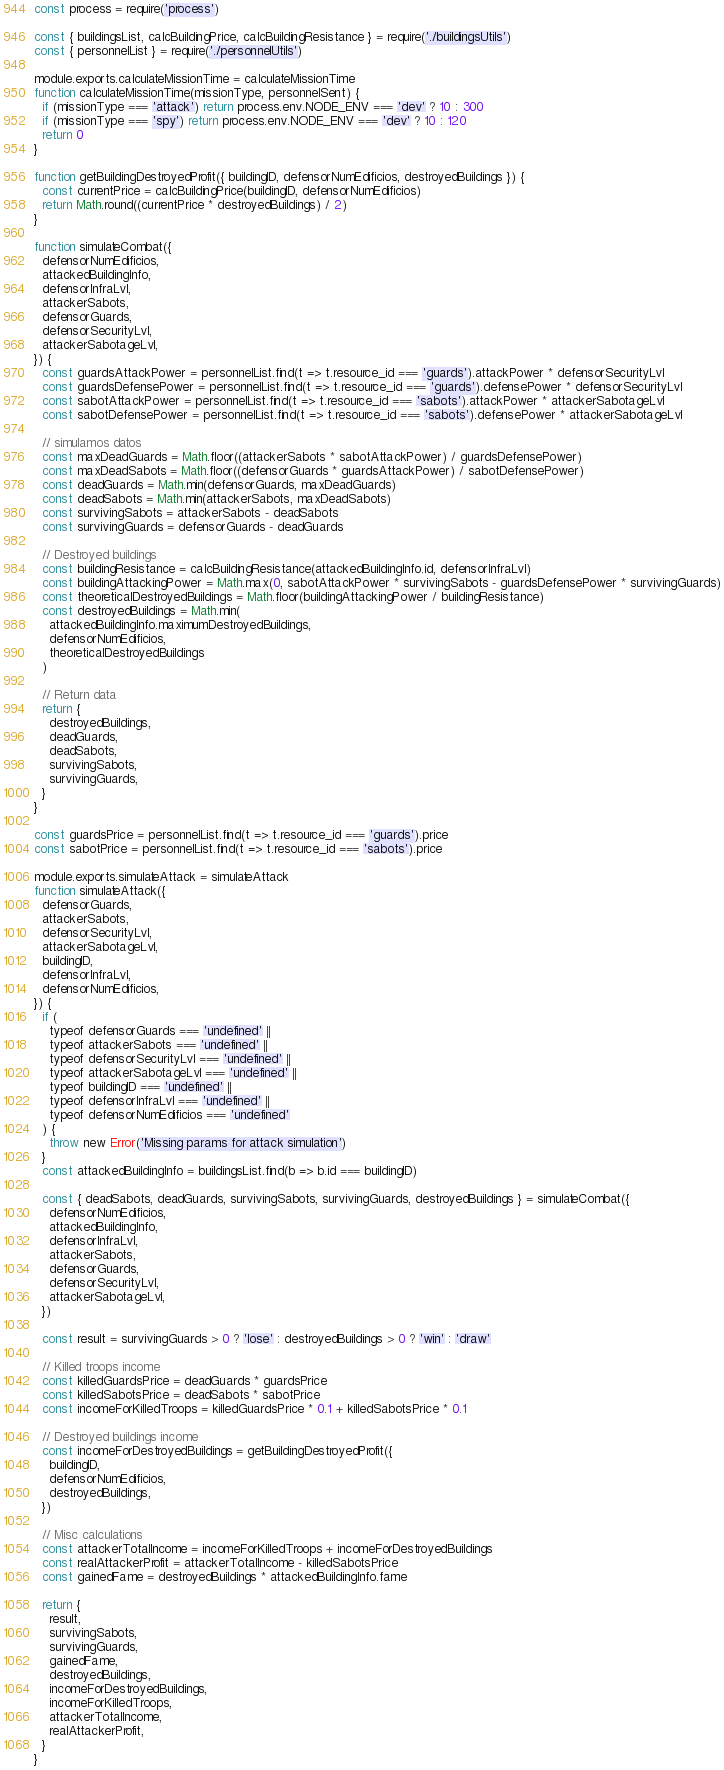<code> <loc_0><loc_0><loc_500><loc_500><_JavaScript_>const process = require('process')

const { buildingsList, calcBuildingPrice, calcBuildingResistance } = require('./buildingsUtils')
const { personnelList } = require('./personnelUtils')

module.exports.calculateMissionTime = calculateMissionTime
function calculateMissionTime(missionType, personnelSent) {
  if (missionType === 'attack') return process.env.NODE_ENV === 'dev' ? 10 : 300
  if (missionType === 'spy') return process.env.NODE_ENV === 'dev' ? 10 : 120
  return 0
}

function getBuildingDestroyedProfit({ buildingID, defensorNumEdificios, destroyedBuildings }) {
  const currentPrice = calcBuildingPrice(buildingID, defensorNumEdificios)
  return Math.round((currentPrice * destroyedBuildings) / 2)
}

function simulateCombat({
  defensorNumEdificios,
  attackedBuildingInfo,
  defensorInfraLvl,
  attackerSabots,
  defensorGuards,
  defensorSecurityLvl,
  attackerSabotageLvl,
}) {
  const guardsAttackPower = personnelList.find(t => t.resource_id === 'guards').attackPower * defensorSecurityLvl
  const guardsDefensePower = personnelList.find(t => t.resource_id === 'guards').defensePower * defensorSecurityLvl
  const sabotAttackPower = personnelList.find(t => t.resource_id === 'sabots').attackPower * attackerSabotageLvl
  const sabotDefensePower = personnelList.find(t => t.resource_id === 'sabots').defensePower * attackerSabotageLvl

  // simulamos datos
  const maxDeadGuards = Math.floor((attackerSabots * sabotAttackPower) / guardsDefensePower)
  const maxDeadSabots = Math.floor((defensorGuards * guardsAttackPower) / sabotDefensePower)
  const deadGuards = Math.min(defensorGuards, maxDeadGuards)
  const deadSabots = Math.min(attackerSabots, maxDeadSabots)
  const survivingSabots = attackerSabots - deadSabots
  const survivingGuards = defensorGuards - deadGuards

  // Destroyed buildings
  const buildingResistance = calcBuildingResistance(attackedBuildingInfo.id, defensorInfraLvl)
  const buildingAttackingPower = Math.max(0, sabotAttackPower * survivingSabots - guardsDefensePower * survivingGuards)
  const theoreticalDestroyedBuildings = Math.floor(buildingAttackingPower / buildingResistance)
  const destroyedBuildings = Math.min(
    attackedBuildingInfo.maximumDestroyedBuildings,
    defensorNumEdificios,
    theoreticalDestroyedBuildings
  )

  // Return data
  return {
    destroyedBuildings,
    deadGuards,
    deadSabots,
    survivingSabots,
    survivingGuards,
  }
}

const guardsPrice = personnelList.find(t => t.resource_id === 'guards').price
const sabotPrice = personnelList.find(t => t.resource_id === 'sabots').price

module.exports.simulateAttack = simulateAttack
function simulateAttack({
  defensorGuards,
  attackerSabots,
  defensorSecurityLvl,
  attackerSabotageLvl,
  buildingID,
  defensorInfraLvl,
  defensorNumEdificios,
}) {
  if (
    typeof defensorGuards === 'undefined' ||
    typeof attackerSabots === 'undefined' ||
    typeof defensorSecurityLvl === 'undefined' ||
    typeof attackerSabotageLvl === 'undefined' ||
    typeof buildingID === 'undefined' ||
    typeof defensorInfraLvl === 'undefined' ||
    typeof defensorNumEdificios === 'undefined'
  ) {
    throw new Error('Missing params for attack simulation')
  }
  const attackedBuildingInfo = buildingsList.find(b => b.id === buildingID)

  const { deadSabots, deadGuards, survivingSabots, survivingGuards, destroyedBuildings } = simulateCombat({
    defensorNumEdificios,
    attackedBuildingInfo,
    defensorInfraLvl,
    attackerSabots,
    defensorGuards,
    defensorSecurityLvl,
    attackerSabotageLvl,
  })

  const result = survivingGuards > 0 ? 'lose' : destroyedBuildings > 0 ? 'win' : 'draw'

  // Killed troops income
  const killedGuardsPrice = deadGuards * guardsPrice
  const killedSabotsPrice = deadSabots * sabotPrice
  const incomeForKilledTroops = killedGuardsPrice * 0.1 + killedSabotsPrice * 0.1

  // Destroyed buildings income
  const incomeForDestroyedBuildings = getBuildingDestroyedProfit({
    buildingID,
    defensorNumEdificios,
    destroyedBuildings,
  })

  // Misc calculations
  const attackerTotalIncome = incomeForKilledTroops + incomeForDestroyedBuildings
  const realAttackerProfit = attackerTotalIncome - killedSabotsPrice
  const gainedFame = destroyedBuildings * attackedBuildingInfo.fame

  return {
    result,
    survivingSabots,
    survivingGuards,
    gainedFame,
    destroyedBuildings,
    incomeForDestroyedBuildings,
    incomeForKilledTroops,
    attackerTotalIncome,
    realAttackerProfit,
  }
}
</code> 